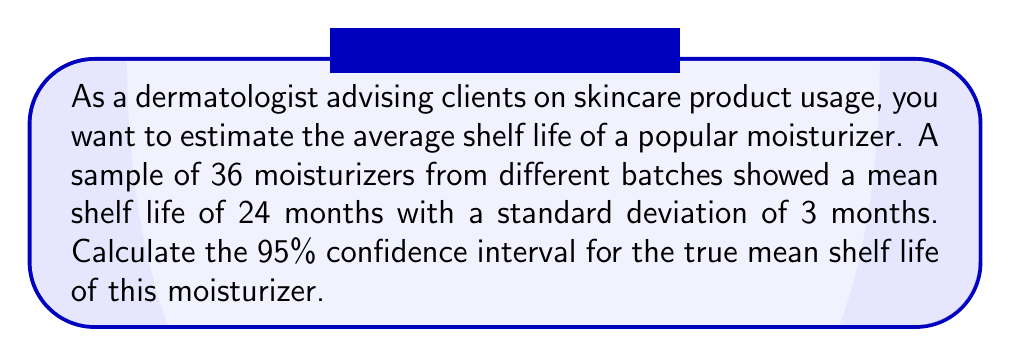What is the answer to this math problem? To calculate the confidence interval, we'll follow these steps:

1. Identify the given information:
   - Sample size (n) = 36
   - Sample mean ($\bar{x}$) = 24 months
   - Sample standard deviation (s) = 3 months
   - Confidence level = 95%

2. Determine the critical value:
   For a 95% confidence interval with df = 35 (n - 1), the t-critical value is approximately 2.030.

3. Calculate the standard error of the mean:
   $SE = \frac{s}{\sqrt{n}} = \frac{3}{\sqrt{36}} = \frac{3}{6} = 0.5$

4. Calculate the margin of error:
   $ME = t_{critical} \times SE = 2.030 \times 0.5 = 1.015$

5. Construct the confidence interval:
   $CI = \bar{x} \pm ME$
   $CI = 24 \pm 1.015$
   $CI = (22.985, 25.015)$

Therefore, we can be 95% confident that the true mean shelf life of the moisturizer falls between 22.985 and 25.015 months.
Answer: (22.985, 25.015) months 